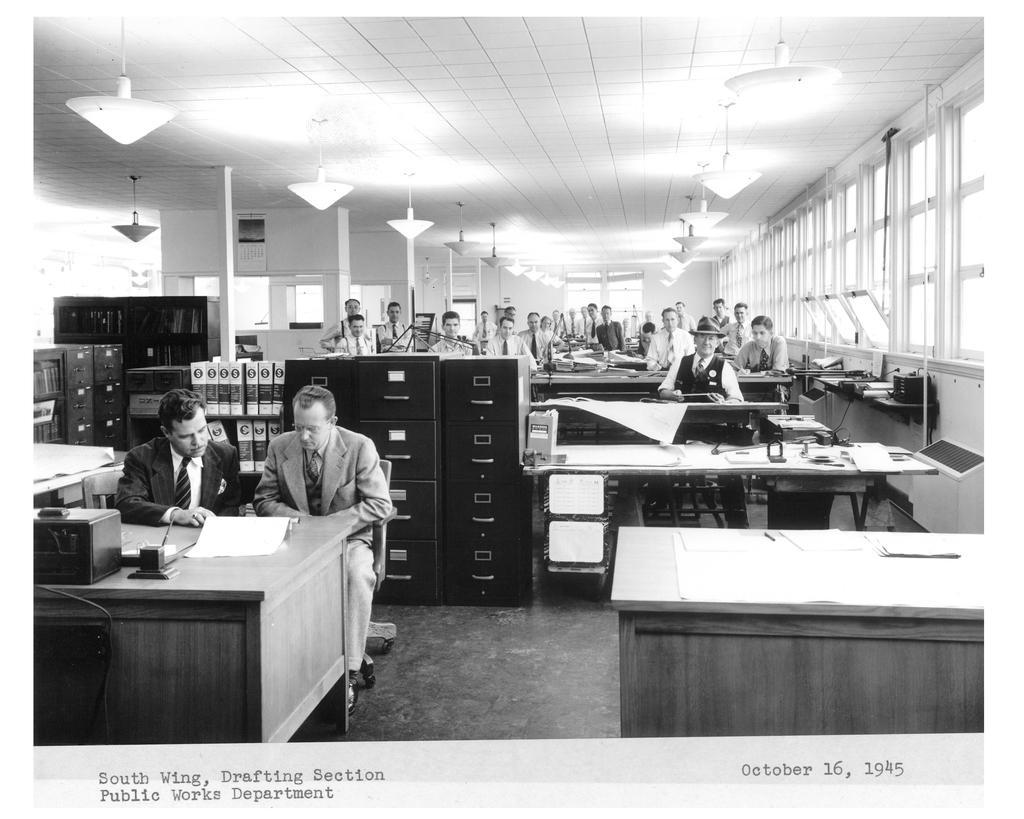Could you give a brief overview of what you see in this image? This is a black and white image and clicked inside the room. In this room I can see few people are sitting on the chairs in front of the tables. On the top of the image there are lights. In this room there are some boxes and files are arranged on the left side of the image. On the right side of the image I can see a window. 